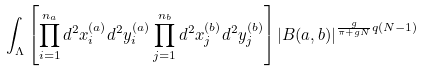Convert formula to latex. <formula><loc_0><loc_0><loc_500><loc_500>\int _ { \Lambda } \left [ \prod _ { i = 1 } ^ { n _ { a } } d ^ { 2 } x _ { i } ^ { ( a ) } d ^ { 2 } y _ { i } ^ { ( a ) } \prod _ { j = 1 } ^ { n _ { b } } d ^ { 2 } x _ { j } ^ { ( b ) } d ^ { 2 } y _ { j } ^ { ( b ) } \right ] \left | B ( a , b ) \right | ^ { \frac { g } { \pi + g N } q ( N - 1 ) } \,</formula> 